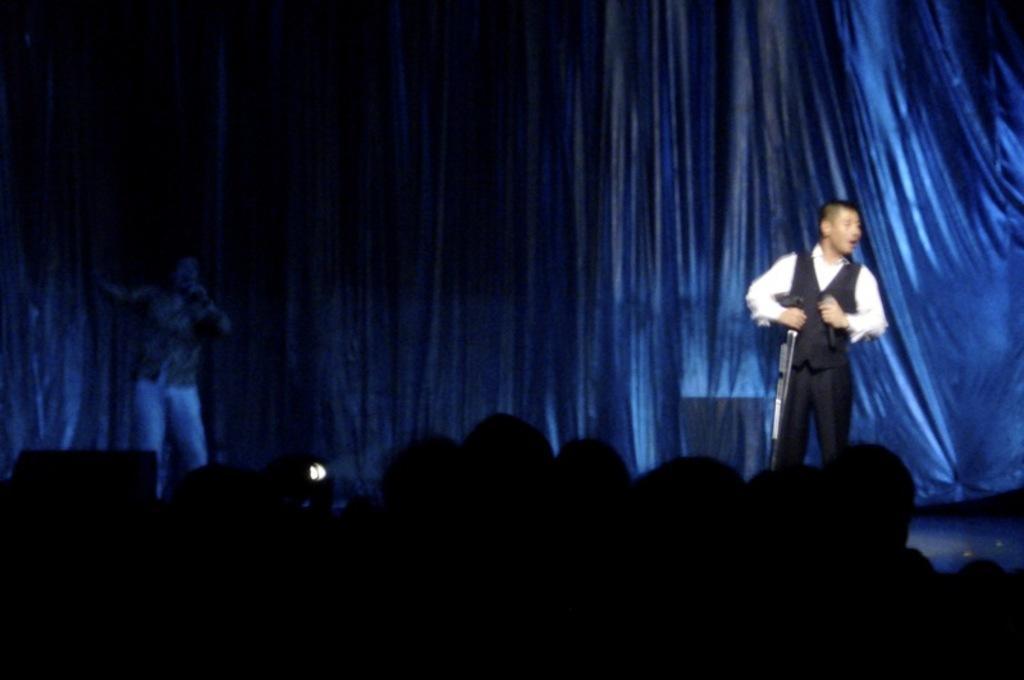Please provide a concise description of this image. In this picture I can see couple of humans performing on the dais and I can see light and a curtain in the back and I can see audience at the bottom of the picture. 